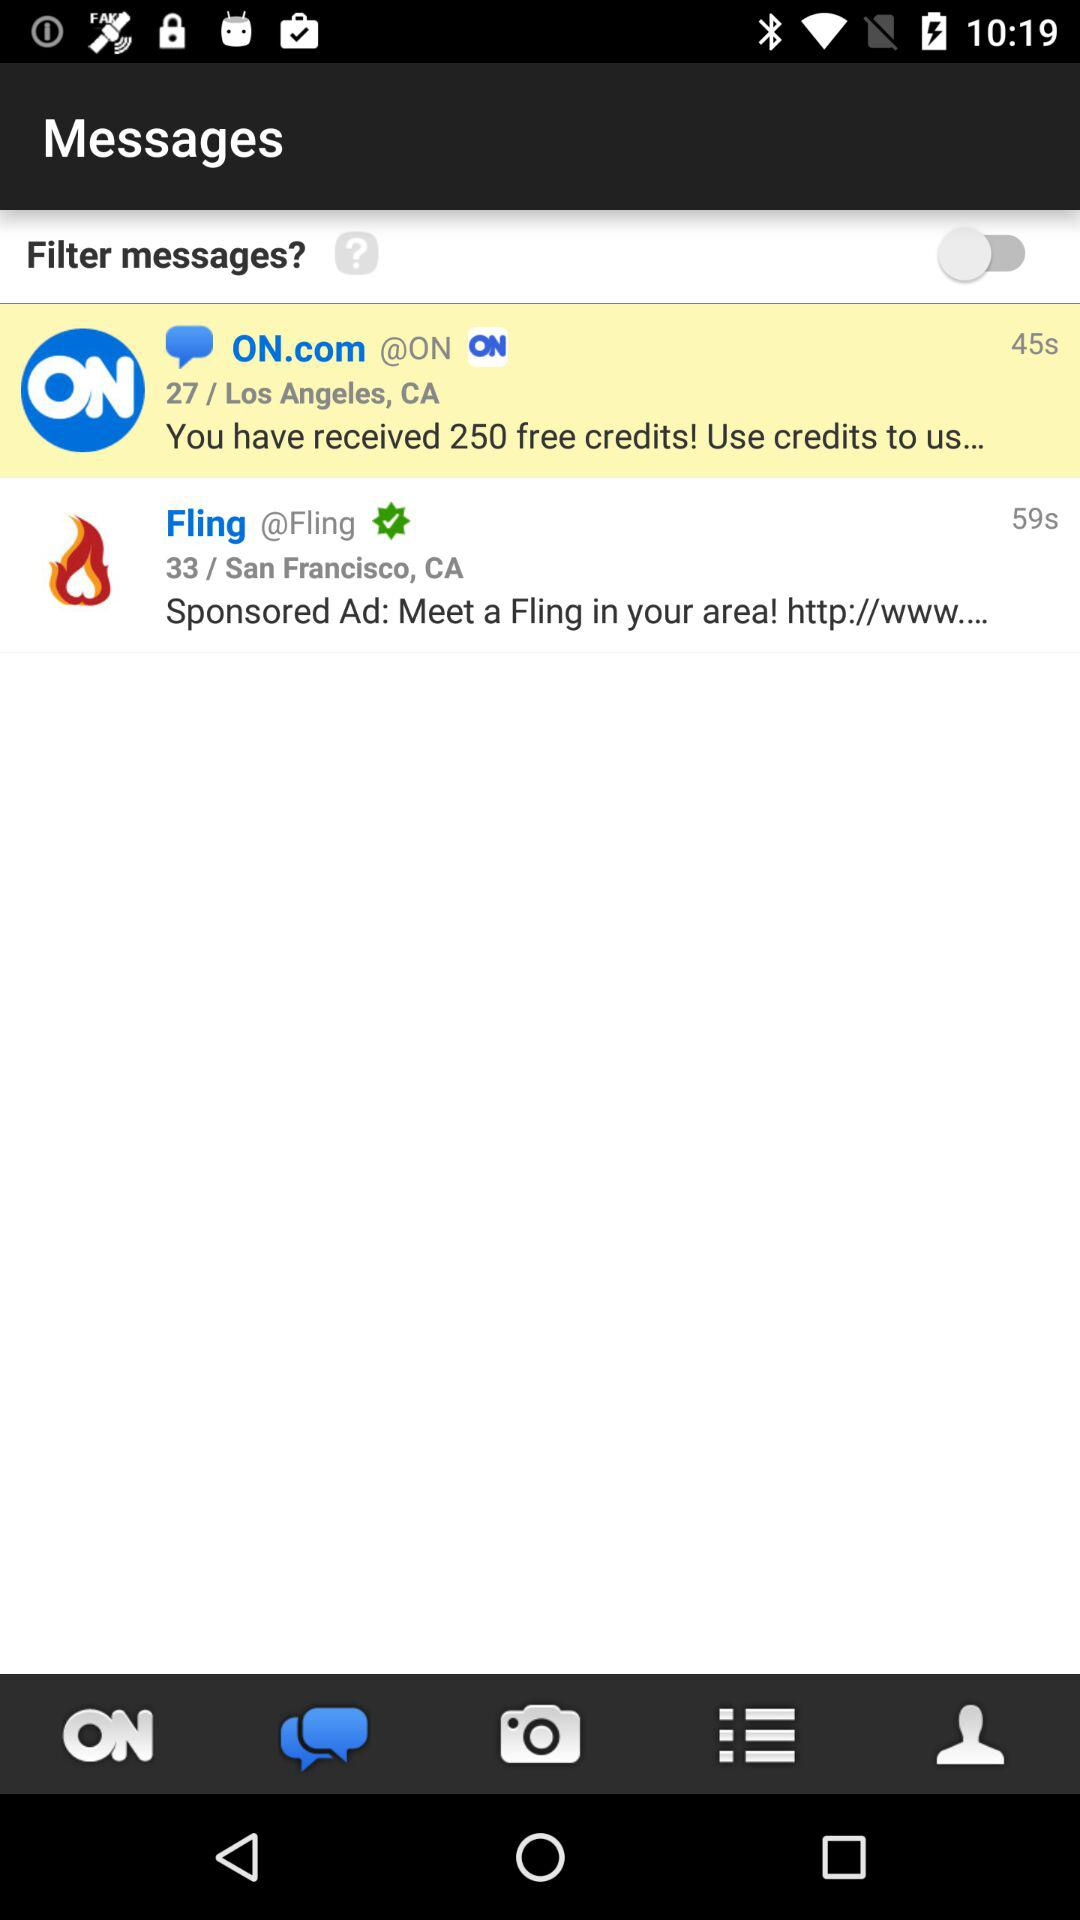What is the location given in second message? The given location is San Francisco, CA. 